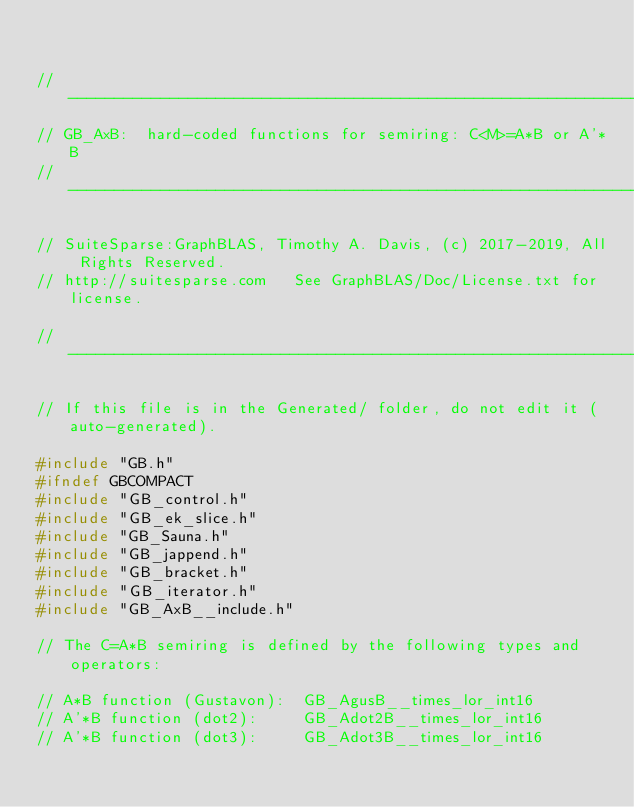<code> <loc_0><loc_0><loc_500><loc_500><_C_>

//------------------------------------------------------------------------------
// GB_AxB:  hard-coded functions for semiring: C<M>=A*B or A'*B
//------------------------------------------------------------------------------

// SuiteSparse:GraphBLAS, Timothy A. Davis, (c) 2017-2019, All Rights Reserved.
// http://suitesparse.com   See GraphBLAS/Doc/License.txt for license.

//------------------------------------------------------------------------------

// If this file is in the Generated/ folder, do not edit it (auto-generated).

#include "GB.h"
#ifndef GBCOMPACT
#include "GB_control.h"
#include "GB_ek_slice.h"
#include "GB_Sauna.h"
#include "GB_jappend.h"
#include "GB_bracket.h"
#include "GB_iterator.h"
#include "GB_AxB__include.h"

// The C=A*B semiring is defined by the following types and operators:

// A*B function (Gustavon):  GB_AgusB__times_lor_int16
// A'*B function (dot2):     GB_Adot2B__times_lor_int16
// A'*B function (dot3):     GB_Adot3B__times_lor_int16</code> 